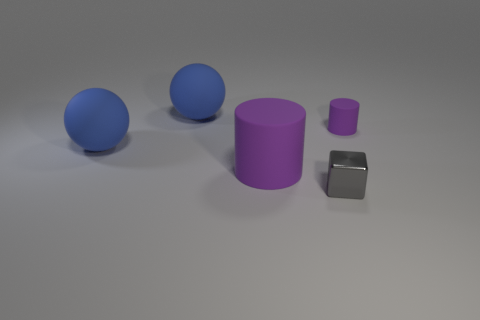Add 2 metallic cubes. How many objects exist? 7 Subtract all cubes. How many objects are left? 4 Add 1 small green objects. How many small green objects exist? 1 Subtract 0 yellow cylinders. How many objects are left? 5 Subtract all large gray shiny spheres. Subtract all small cylinders. How many objects are left? 4 Add 5 purple matte cylinders. How many purple matte cylinders are left? 7 